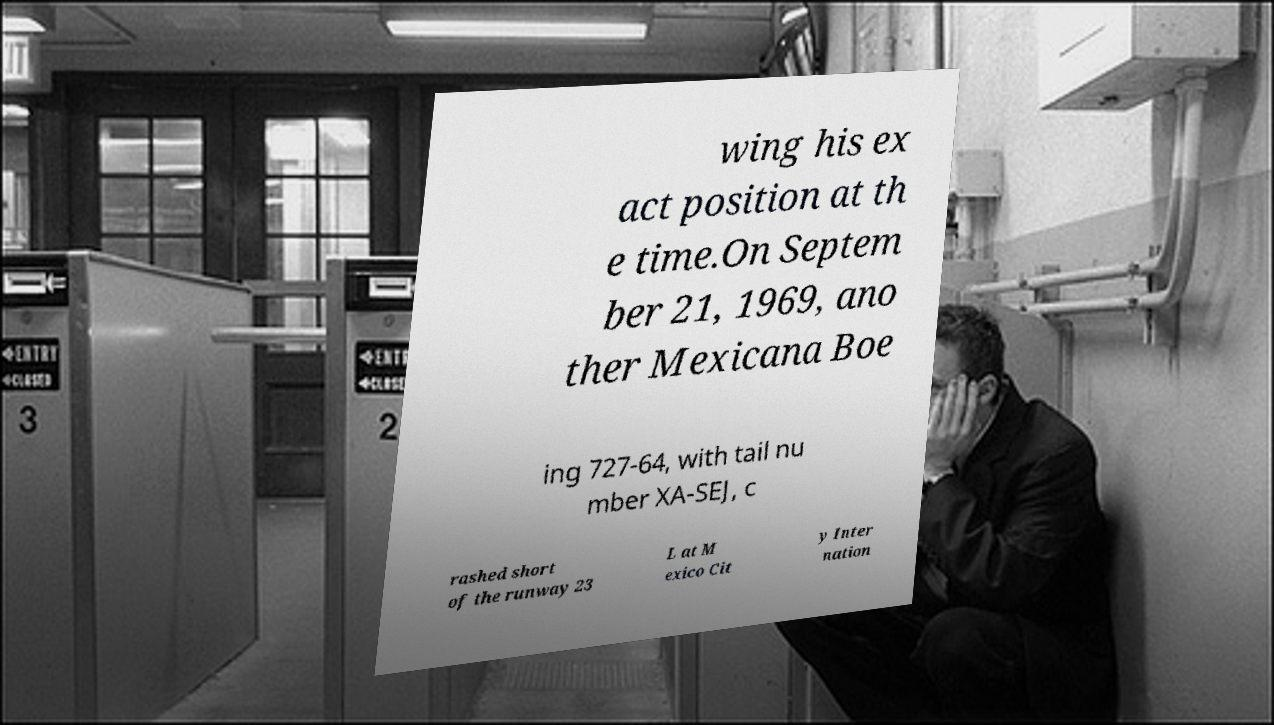There's text embedded in this image that I need extracted. Can you transcribe it verbatim? wing his ex act position at th e time.On Septem ber 21, 1969, ano ther Mexicana Boe ing 727-64, with tail nu mber XA-SEJ, c rashed short of the runway 23 L at M exico Cit y Inter nation 